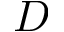Convert formula to latex. <formula><loc_0><loc_0><loc_500><loc_500>D</formula> 